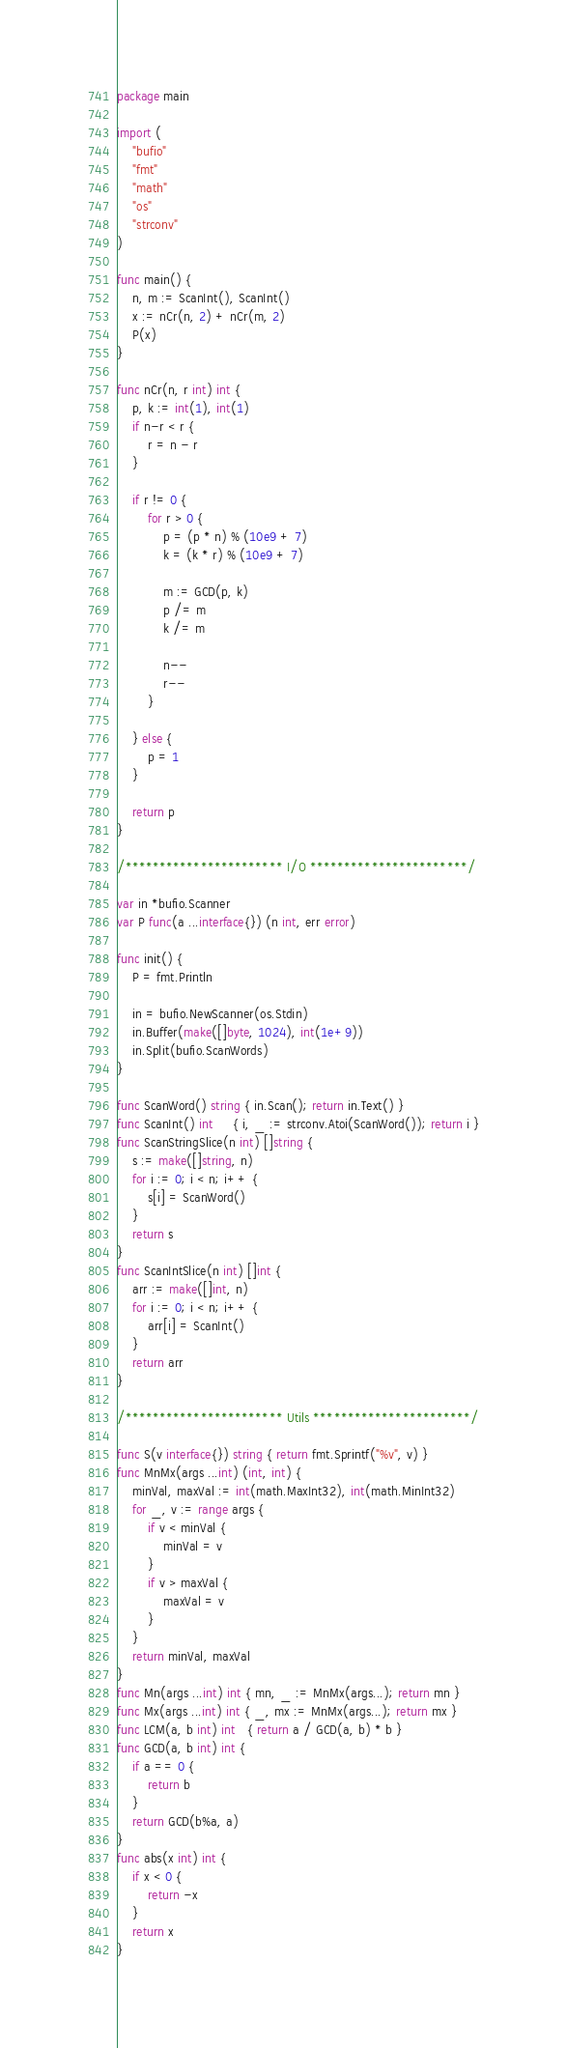<code> <loc_0><loc_0><loc_500><loc_500><_Go_>package main

import (
	"bufio"
	"fmt"
	"math"
	"os"
	"strconv"
)

func main() {
	n, m := ScanInt(), ScanInt()
	x := nCr(n, 2) + nCr(m, 2)
	P(x)
}

func nCr(n, r int) int {
	p, k := int(1), int(1)
	if n-r < r {
		r = n - r
	}

	if r != 0 {
		for r > 0 {
			p = (p * n) % (10e9 + 7)
			k = (k * r) % (10e9 + 7)

			m := GCD(p, k)
			p /= m
			k /= m

			n--
			r--
		}

	} else {
		p = 1
	}

	return p
}

/*********************** I/O ***********************/

var in *bufio.Scanner
var P func(a ...interface{}) (n int, err error)

func init() {
	P = fmt.Println

	in = bufio.NewScanner(os.Stdin)
	in.Buffer(make([]byte, 1024), int(1e+9))
	in.Split(bufio.ScanWords)
}

func ScanWord() string { in.Scan(); return in.Text() }
func ScanInt() int     { i, _ := strconv.Atoi(ScanWord()); return i }
func ScanStringSlice(n int) []string {
	s := make([]string, n)
	for i := 0; i < n; i++ {
		s[i] = ScanWord()
	}
	return s
}
func ScanIntSlice(n int) []int {
	arr := make([]int, n)
	for i := 0; i < n; i++ {
		arr[i] = ScanInt()
	}
	return arr
}

/*********************** Utils ***********************/

func S(v interface{}) string { return fmt.Sprintf("%v", v) }
func MnMx(args ...int) (int, int) {
	minVal, maxVal := int(math.MaxInt32), int(math.MinInt32)
	for _, v := range args {
		if v < minVal {
			minVal = v
		}
		if v > maxVal {
			maxVal = v
		}
	}
	return minVal, maxVal
}
func Mn(args ...int) int { mn, _ := MnMx(args...); return mn }
func Mx(args ...int) int { _, mx := MnMx(args...); return mx }
func LCM(a, b int) int   { return a / GCD(a, b) * b }
func GCD(a, b int) int {
	if a == 0 {
		return b
	}
	return GCD(b%a, a)
}
func abs(x int) int {
	if x < 0 {
		return -x
	}
	return x
}
</code> 